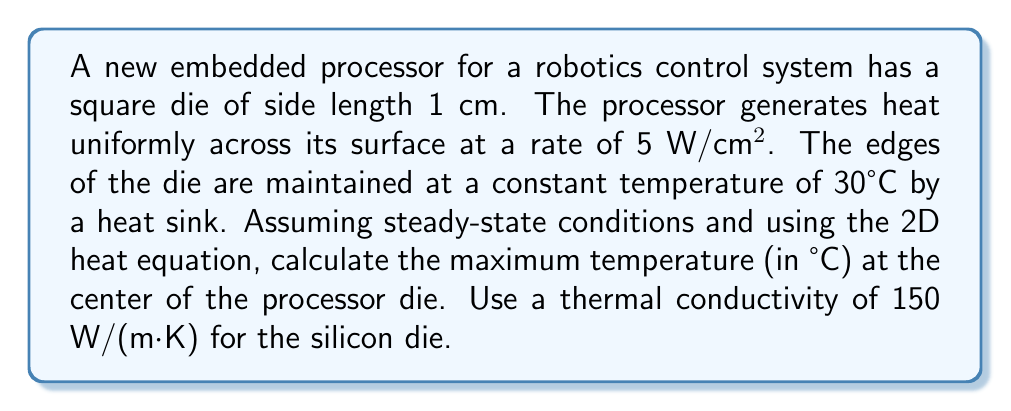What is the answer to this math problem? To solve this problem, we'll use the 2D steady-state heat equation with a heat source:

$$\frac{\partial^2 T}{\partial x^2} + \frac{\partial^2 T}{\partial y^2} + \frac{q}{k} = 0$$

Where:
- $T$ is temperature
- $q$ is the heat generation rate per unit volume
- $k$ is the thermal conductivity

Given:
- Die size: 1 cm × 1 cm
- Heat generation: $q' = 5$ W/cm² (surface heat flux)
- Edge temperature: 30°C
- Thermal conductivity: $k = 150$ W/(m·K)

Step 1: Convert the surface heat flux to volumetric heat generation.
Assuming a die thickness of 1 mm:
$q = q' / \text{thickness} = 5 \text{ W/cm²} / 0.1 \text{ cm} = 50 \text{ W/cm³} = 5 \times 10^6 \text{ W/m³}$

Step 2: Due to symmetry, we can simplify the problem to a 1D case from the edge to the center (half of the die width):
$$\frac{d^2 T}{dx^2} + \frac{q}{k} = 0$$

Step 3: Integrate twice:
$$\frac{dT}{dx} = -\frac{q}{k}x + C_1$$
$$T = -\frac{q}{2k}x^2 + C_1x + C_2$$

Step 4: Apply boundary conditions:
At $x = 0$ (edge): $T = 30°C$
At $x = 0.005$ m (center): $\frac{dT}{dx} = 0$ (symmetry)

Step 5: Solve for constants:
$C_2 = 30$
$C_1 = \frac{q}{k} \cdot 0.005$

Step 6: Final temperature distribution:
$$T = -\frac{q}{2k}x^2 + \frac{q}{k} \cdot 0.005x + 30$$

Step 7: Calculate maximum temperature at the center ($x = 0.005$ m):
$$T_{max} = -\frac{5 \times 10^6}{2 \cdot 150}(0.005)^2 + \frac{5 \times 10^6}{150} \cdot 0.005 \cdot 0.005 + 30$$
$$T_{max} = -0.4167 + 0.8333 + 30 = 30.4167°C$$
Answer: 30.42°C 